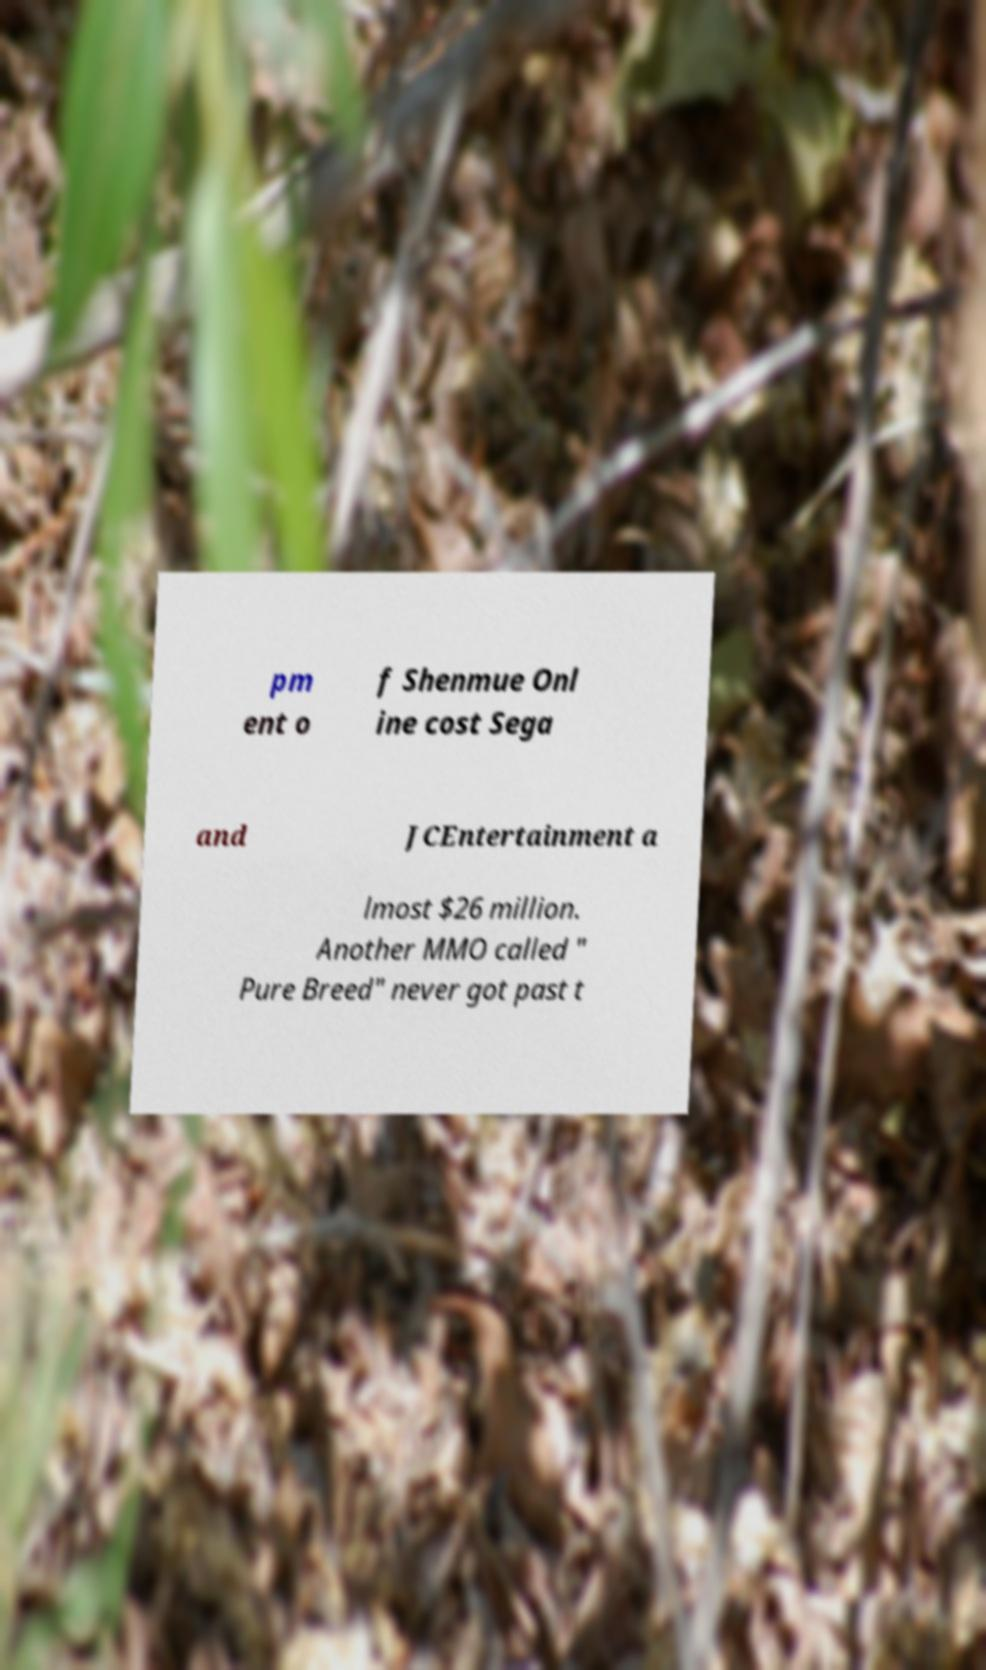I need the written content from this picture converted into text. Can you do that? pm ent o f Shenmue Onl ine cost Sega and JCEntertainment a lmost $26 million. Another MMO called " Pure Breed" never got past t 